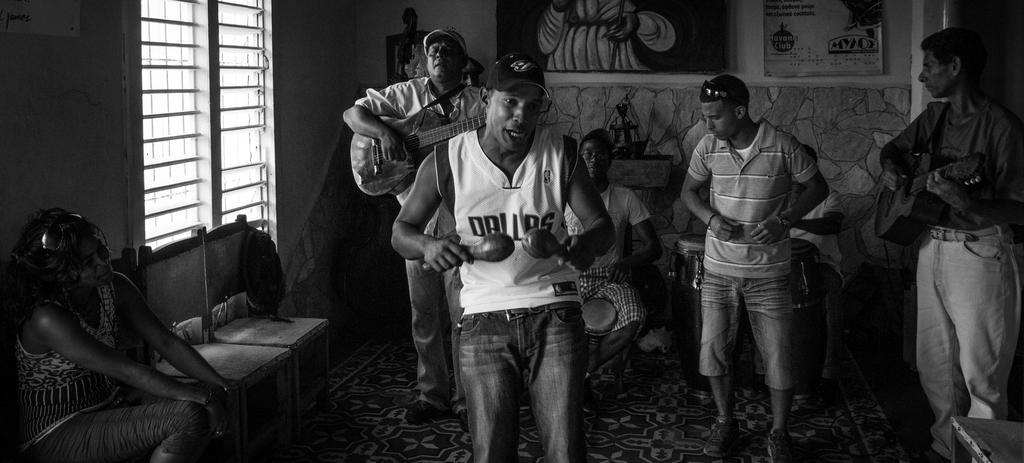Please provide a concise description of this image. this black and white image is clicked inside a room. There are few people standing and few people sitting. The woman to the left corner is sitting and watching the the musicians. The man in the center is playing a musical instrument and also seems like he is singing. The man behind him is playing guitar. The man to the right corner is also playing guitar and beside him there is a man standing. Behind them there are two people sitting and playing drums. In the background there is wall and picture frames are hanging on the wall. 